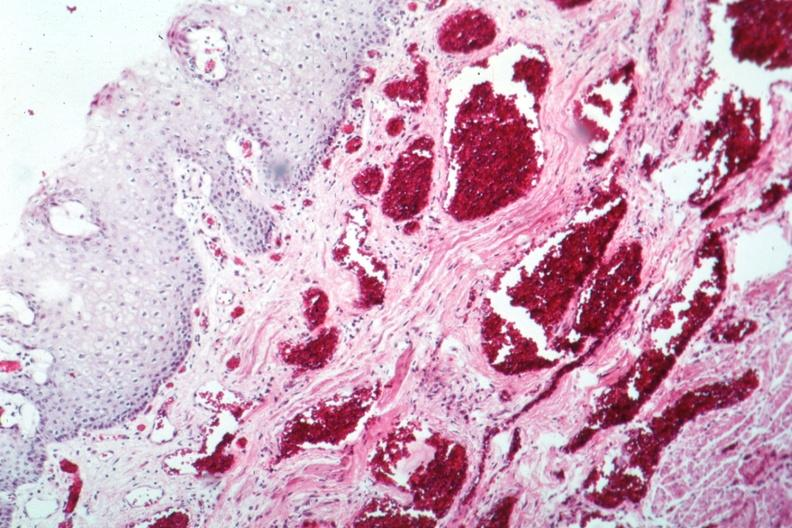s syndactyly present?
Answer the question using a single word or phrase. No 